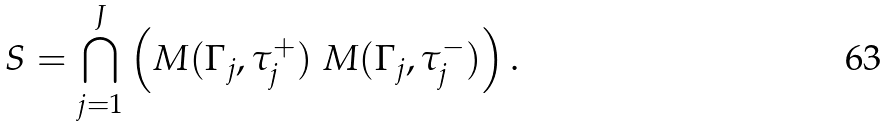<formula> <loc_0><loc_0><loc_500><loc_500>S = \bigcap _ { j = 1 } ^ { J } \left ( M ( \Gamma _ { j } , \tau _ { j } ^ { + } ) \ M ( \Gamma _ { j } , \tau _ { j } ^ { - } ) \right ) .</formula> 